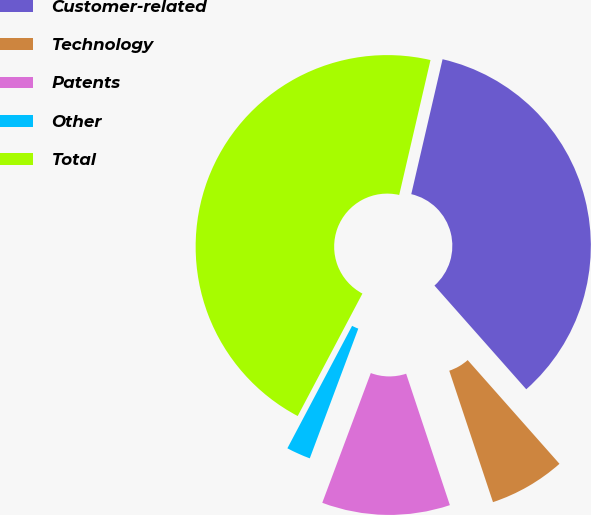Convert chart to OTSL. <chart><loc_0><loc_0><loc_500><loc_500><pie_chart><fcel>Customer-related<fcel>Technology<fcel>Patents<fcel>Other<fcel>Total<nl><fcel>34.84%<fcel>6.42%<fcel>10.81%<fcel>2.04%<fcel>45.89%<nl></chart> 